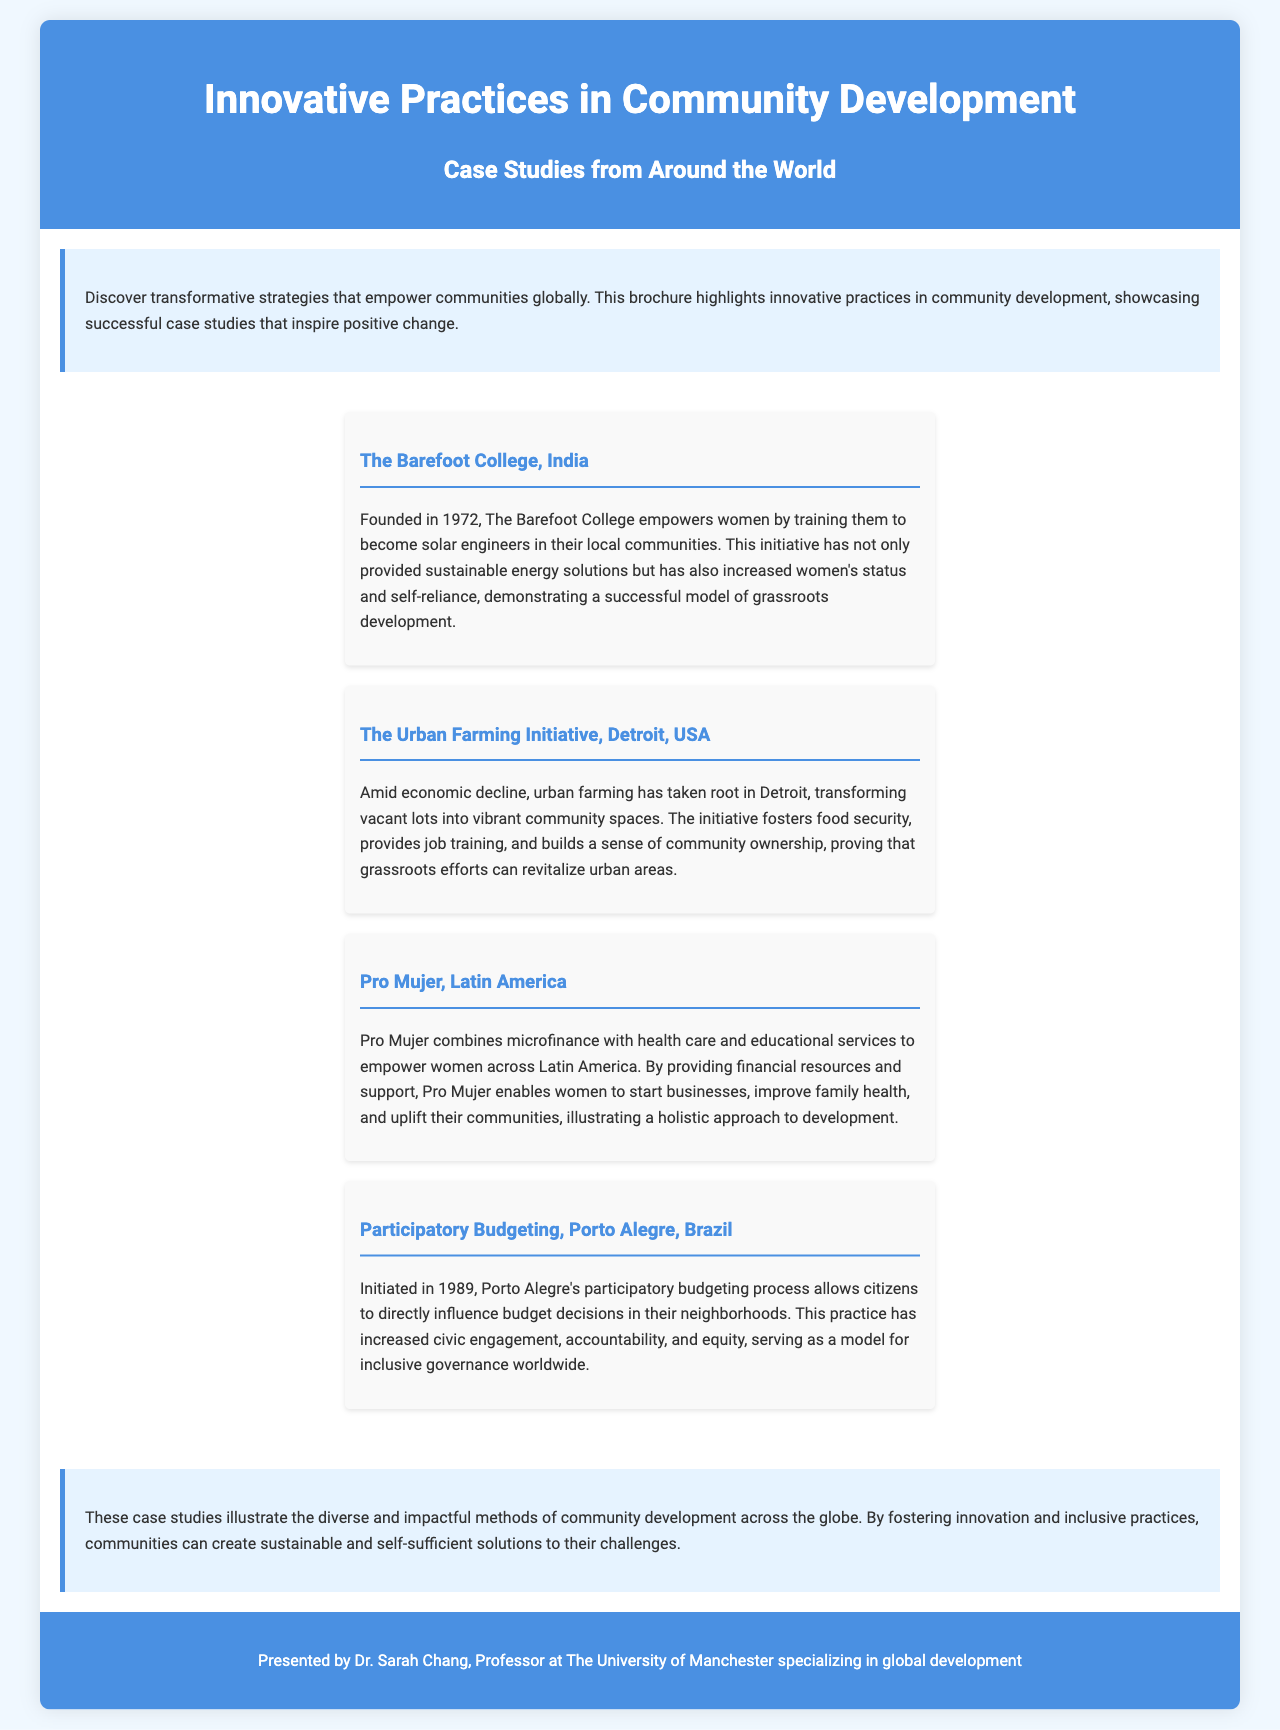what is the title of the brochure? The title is prominently displayed at the top of the brochure and indicates the main focus of the document.
Answer: Innovative Practices in Community Development who is the author of the brochure? The author is presented in the footer of the brochure, indicating her affiliation with the university.
Answer: Dr. Sarah Chang when was The Barefoot College founded? The founding year of The Barefoot College is mentioned in the case study section, providing historical context.
Answer: 1972 what initiative does The Urban Farming Initiative focus on? The focus of The Urban Farming Initiative is clearly articulated in the case study, emphasizing its main goal.
Answer: urban farming which city is associated with the Participatory Budgeting case study? The city is specified in the case study title, indicating where the initiative takes place.
Answer: Porto Alegre how many case studies are presented in total? The total number of case studies is indicated by the visible list organized within the brochure.
Answer: four what main benefit does Pro Mujer provide to women? The main benefit is highlighted in the case study, summarizing the core service offered.
Answer: microfinance which continent is represented by Pro Mujer? The geographic focus is mentioned in the description of the initiative, indicating the regions served.
Answer: Latin America what type of governance does Porto Alegre's initiative promote? The type of governance is discussed in relation to the outcomes observed from the participatory process.
Answer: inclusive 